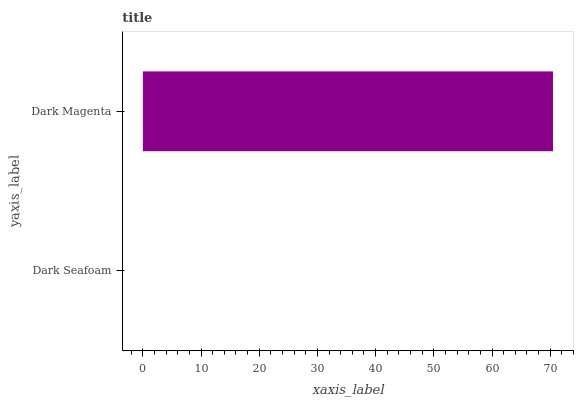Is Dark Seafoam the minimum?
Answer yes or no. Yes. Is Dark Magenta the maximum?
Answer yes or no. Yes. Is Dark Magenta the minimum?
Answer yes or no. No. Is Dark Magenta greater than Dark Seafoam?
Answer yes or no. Yes. Is Dark Seafoam less than Dark Magenta?
Answer yes or no. Yes. Is Dark Seafoam greater than Dark Magenta?
Answer yes or no. No. Is Dark Magenta less than Dark Seafoam?
Answer yes or no. No. Is Dark Magenta the high median?
Answer yes or no. Yes. Is Dark Seafoam the low median?
Answer yes or no. Yes. Is Dark Seafoam the high median?
Answer yes or no. No. Is Dark Magenta the low median?
Answer yes or no. No. 